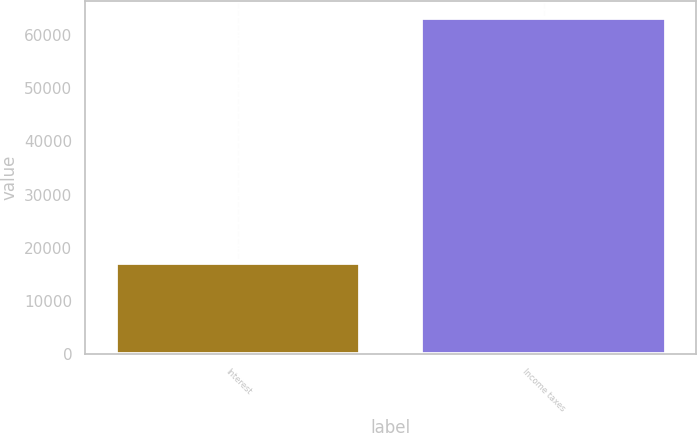Convert chart to OTSL. <chart><loc_0><loc_0><loc_500><loc_500><bar_chart><fcel>Interest<fcel>Income taxes<nl><fcel>17217<fcel>63196<nl></chart> 